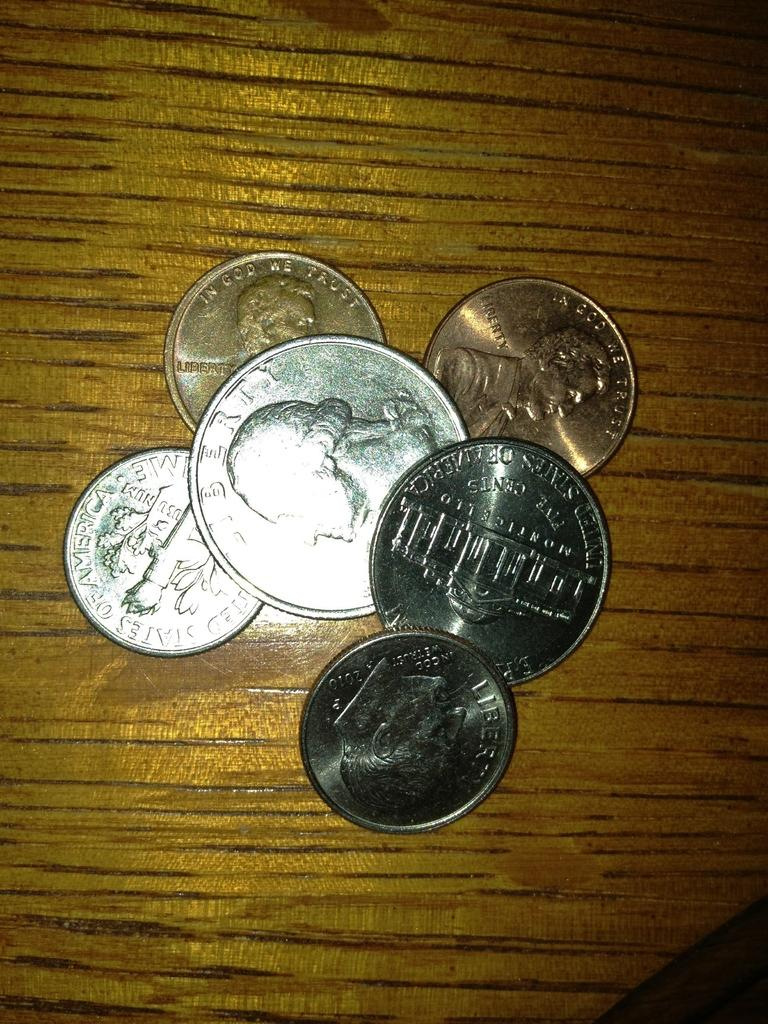Provide a one-sentence caption for the provided image. Six US coins, including a five cent and a dime coin, are piled on a wooden surface. 